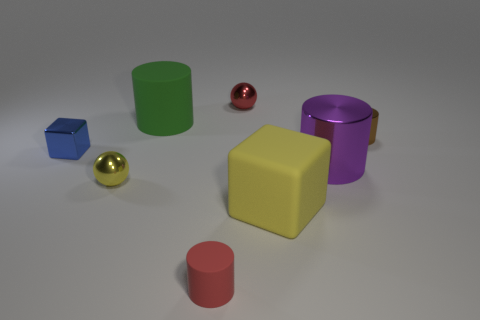Subtract 1 cylinders. How many cylinders are left? 3 Subtract all cyan spheres. Subtract all blue cylinders. How many spheres are left? 2 Add 2 brown matte blocks. How many objects exist? 10 Subtract all blocks. How many objects are left? 6 Add 2 tiny blocks. How many tiny blocks exist? 3 Subtract 0 gray balls. How many objects are left? 8 Subtract all blue matte cylinders. Subtract all small cylinders. How many objects are left? 6 Add 5 rubber cylinders. How many rubber cylinders are left? 7 